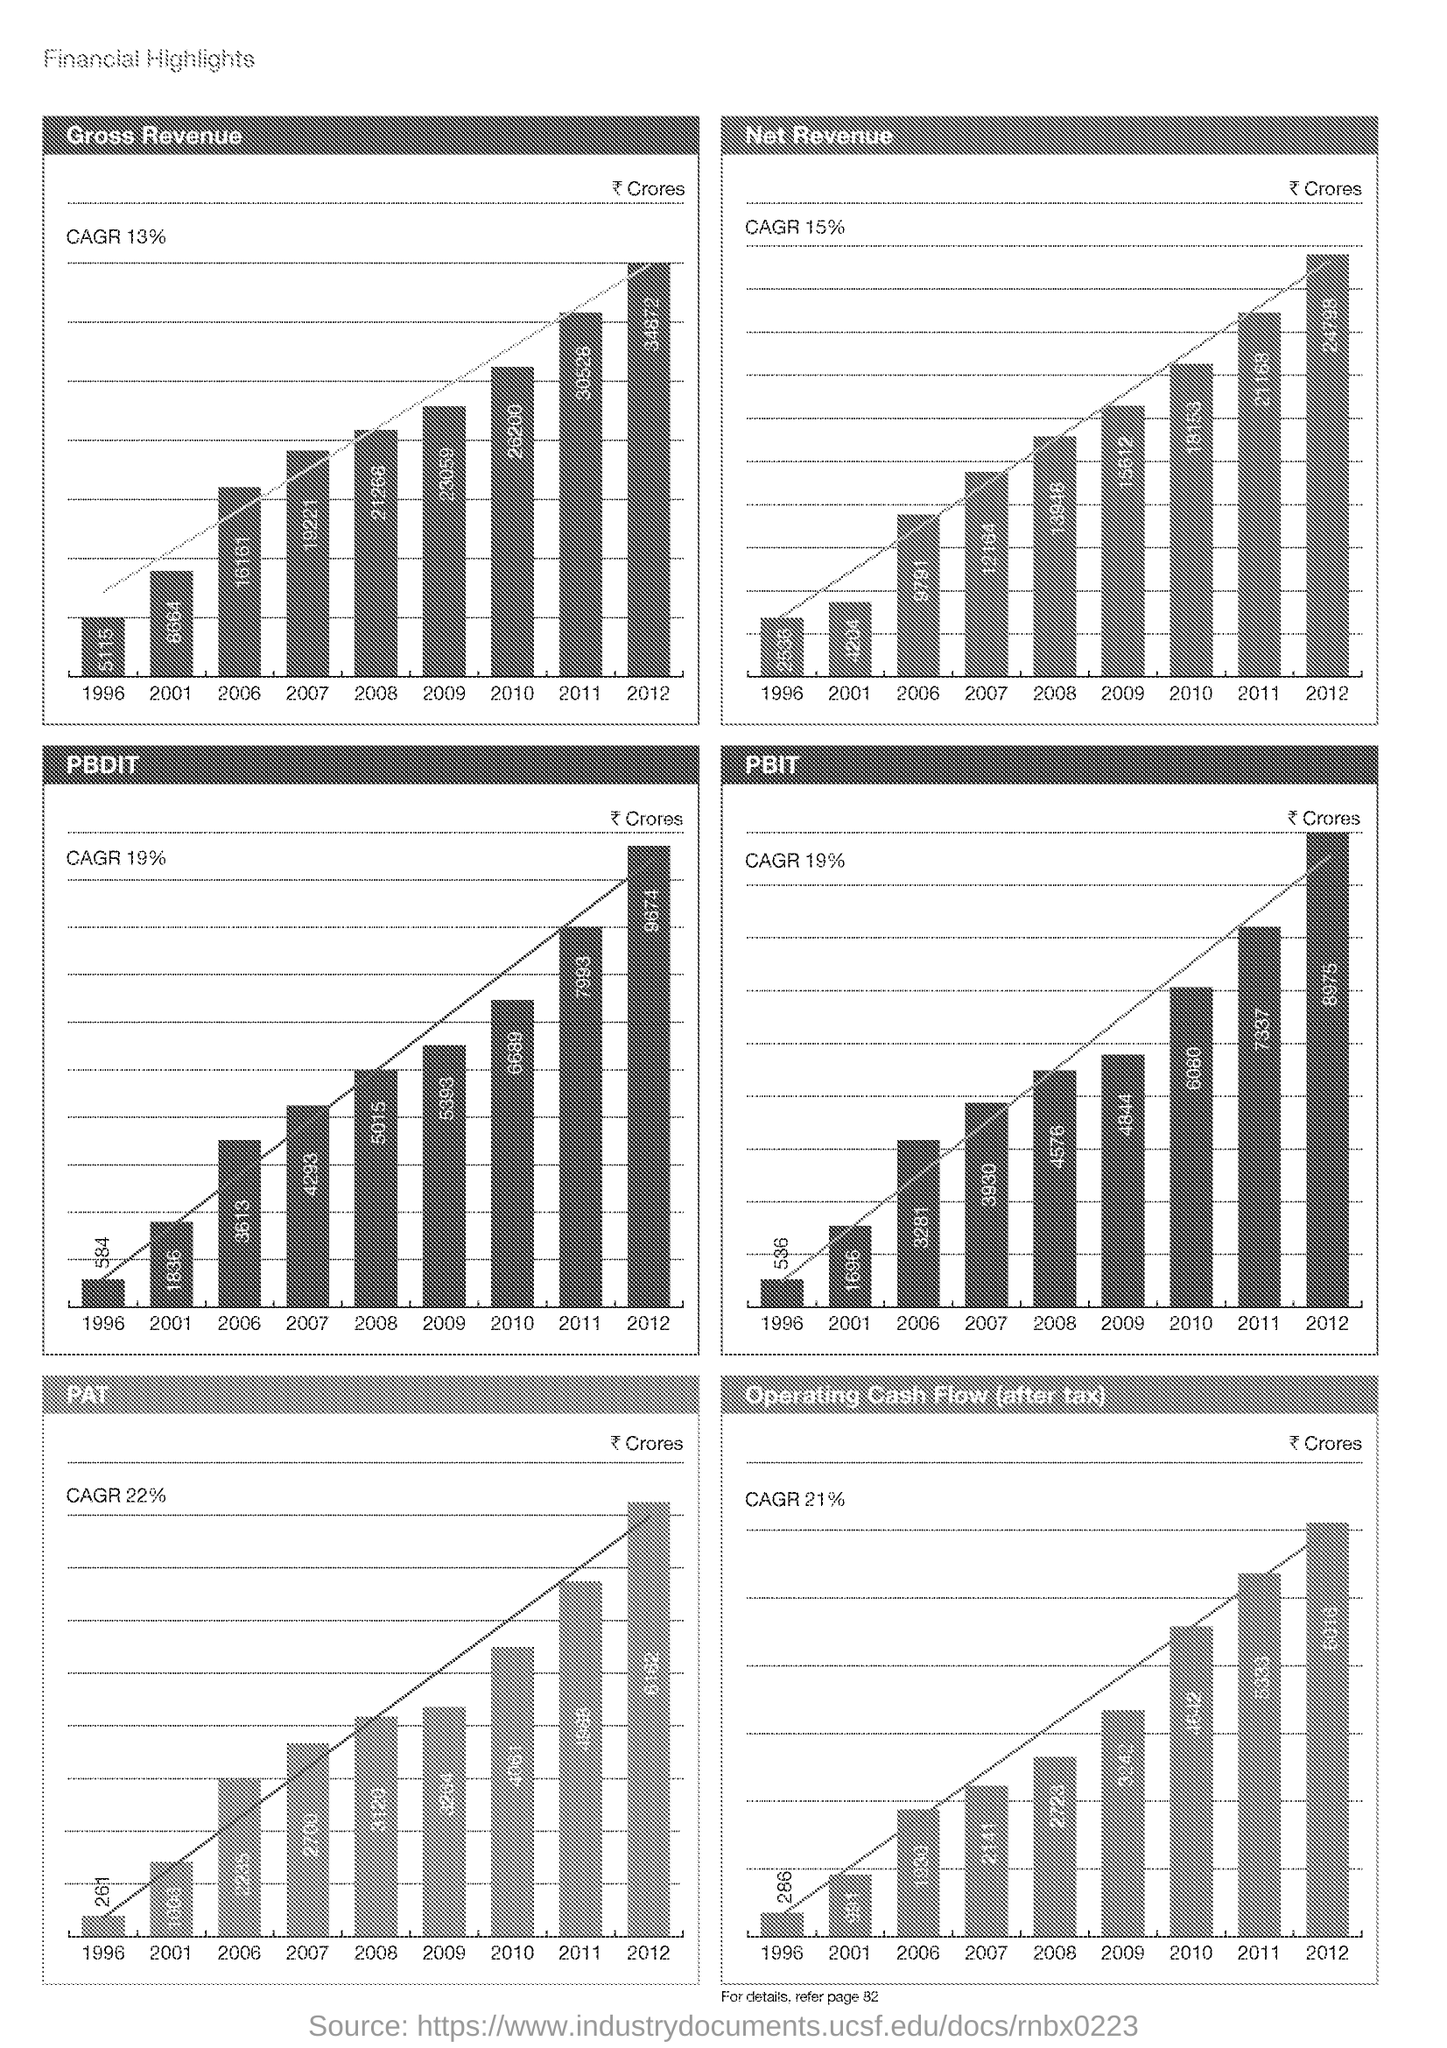What is the Percentage for Gross Revenue?
Your answer should be very brief. CAGR 13%. 